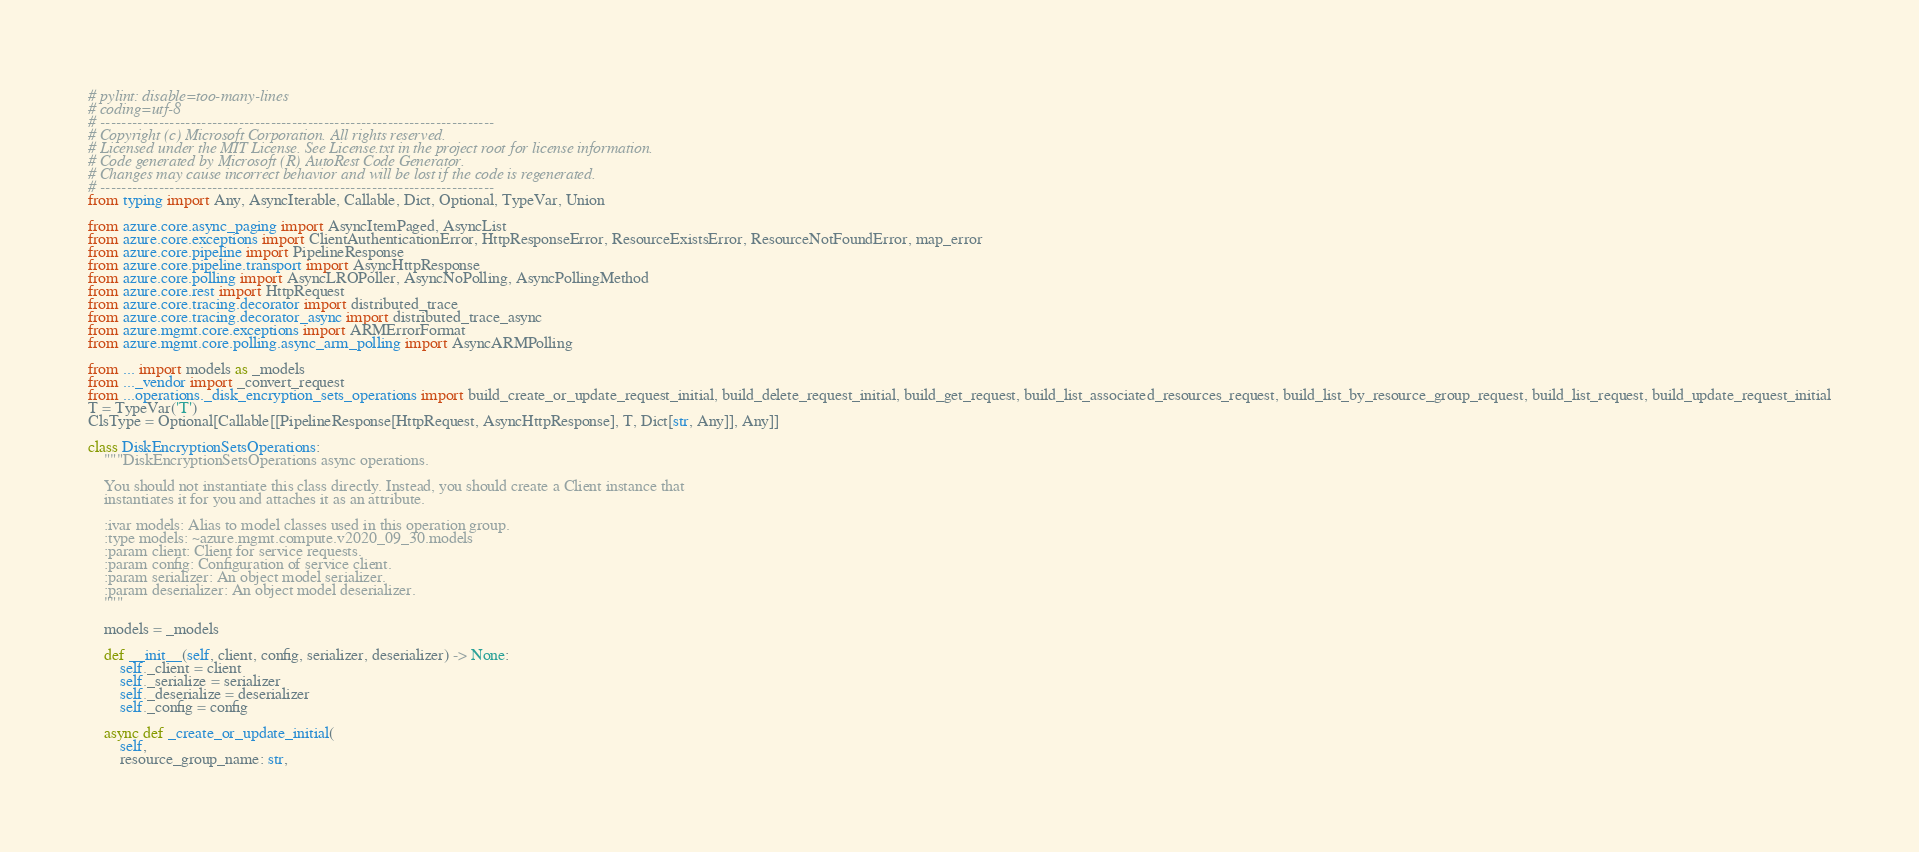<code> <loc_0><loc_0><loc_500><loc_500><_Python_># pylint: disable=too-many-lines
# coding=utf-8
# --------------------------------------------------------------------------
# Copyright (c) Microsoft Corporation. All rights reserved.
# Licensed under the MIT License. See License.txt in the project root for license information.
# Code generated by Microsoft (R) AutoRest Code Generator.
# Changes may cause incorrect behavior and will be lost if the code is regenerated.
# --------------------------------------------------------------------------
from typing import Any, AsyncIterable, Callable, Dict, Optional, TypeVar, Union

from azure.core.async_paging import AsyncItemPaged, AsyncList
from azure.core.exceptions import ClientAuthenticationError, HttpResponseError, ResourceExistsError, ResourceNotFoundError, map_error
from azure.core.pipeline import PipelineResponse
from azure.core.pipeline.transport import AsyncHttpResponse
from azure.core.polling import AsyncLROPoller, AsyncNoPolling, AsyncPollingMethod
from azure.core.rest import HttpRequest
from azure.core.tracing.decorator import distributed_trace
from azure.core.tracing.decorator_async import distributed_trace_async
from azure.mgmt.core.exceptions import ARMErrorFormat
from azure.mgmt.core.polling.async_arm_polling import AsyncARMPolling

from ... import models as _models
from ..._vendor import _convert_request
from ...operations._disk_encryption_sets_operations import build_create_or_update_request_initial, build_delete_request_initial, build_get_request, build_list_associated_resources_request, build_list_by_resource_group_request, build_list_request, build_update_request_initial
T = TypeVar('T')
ClsType = Optional[Callable[[PipelineResponse[HttpRequest, AsyncHttpResponse], T, Dict[str, Any]], Any]]

class DiskEncryptionSetsOperations:
    """DiskEncryptionSetsOperations async operations.

    You should not instantiate this class directly. Instead, you should create a Client instance that
    instantiates it for you and attaches it as an attribute.

    :ivar models: Alias to model classes used in this operation group.
    :type models: ~azure.mgmt.compute.v2020_09_30.models
    :param client: Client for service requests.
    :param config: Configuration of service client.
    :param serializer: An object model serializer.
    :param deserializer: An object model deserializer.
    """

    models = _models

    def __init__(self, client, config, serializer, deserializer) -> None:
        self._client = client
        self._serialize = serializer
        self._deserialize = deserializer
        self._config = config

    async def _create_or_update_initial(
        self,
        resource_group_name: str,</code> 